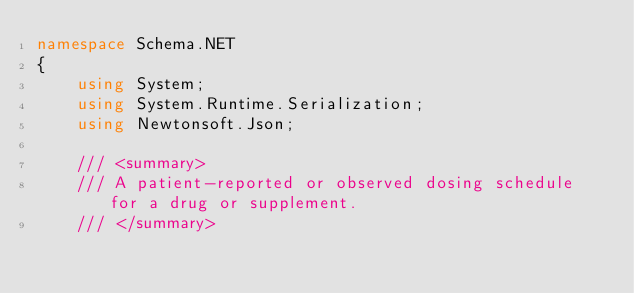<code> <loc_0><loc_0><loc_500><loc_500><_C#_>namespace Schema.NET
{
    using System;
    using System.Runtime.Serialization;
    using Newtonsoft.Json;

    /// <summary>
    /// A patient-reported or observed dosing schedule for a drug or supplement.
    /// </summary></code> 